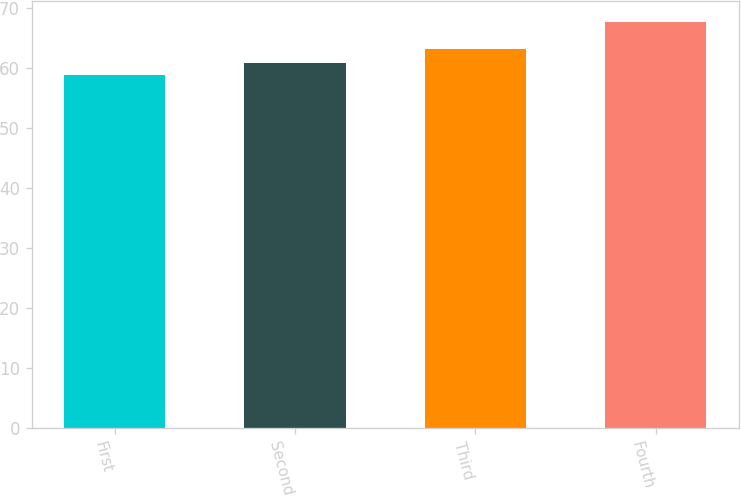<chart> <loc_0><loc_0><loc_500><loc_500><bar_chart><fcel>First<fcel>Second<fcel>Third<fcel>Fourth<nl><fcel>58.89<fcel>60.91<fcel>63.23<fcel>67.79<nl></chart> 